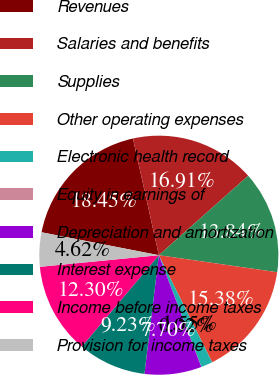Convert chart to OTSL. <chart><loc_0><loc_0><loc_500><loc_500><pie_chart><fcel>Revenues<fcel>Salaries and benefits<fcel>Supplies<fcel>Other operating expenses<fcel>Electronic health record<fcel>Equity in earnings of<fcel>Depreciation and amortization<fcel>Interest expense<fcel>Income before income taxes<fcel>Provision for income taxes<nl><fcel>18.45%<fcel>16.91%<fcel>13.84%<fcel>15.38%<fcel>1.55%<fcel>0.02%<fcel>7.7%<fcel>9.23%<fcel>12.3%<fcel>4.62%<nl></chart> 